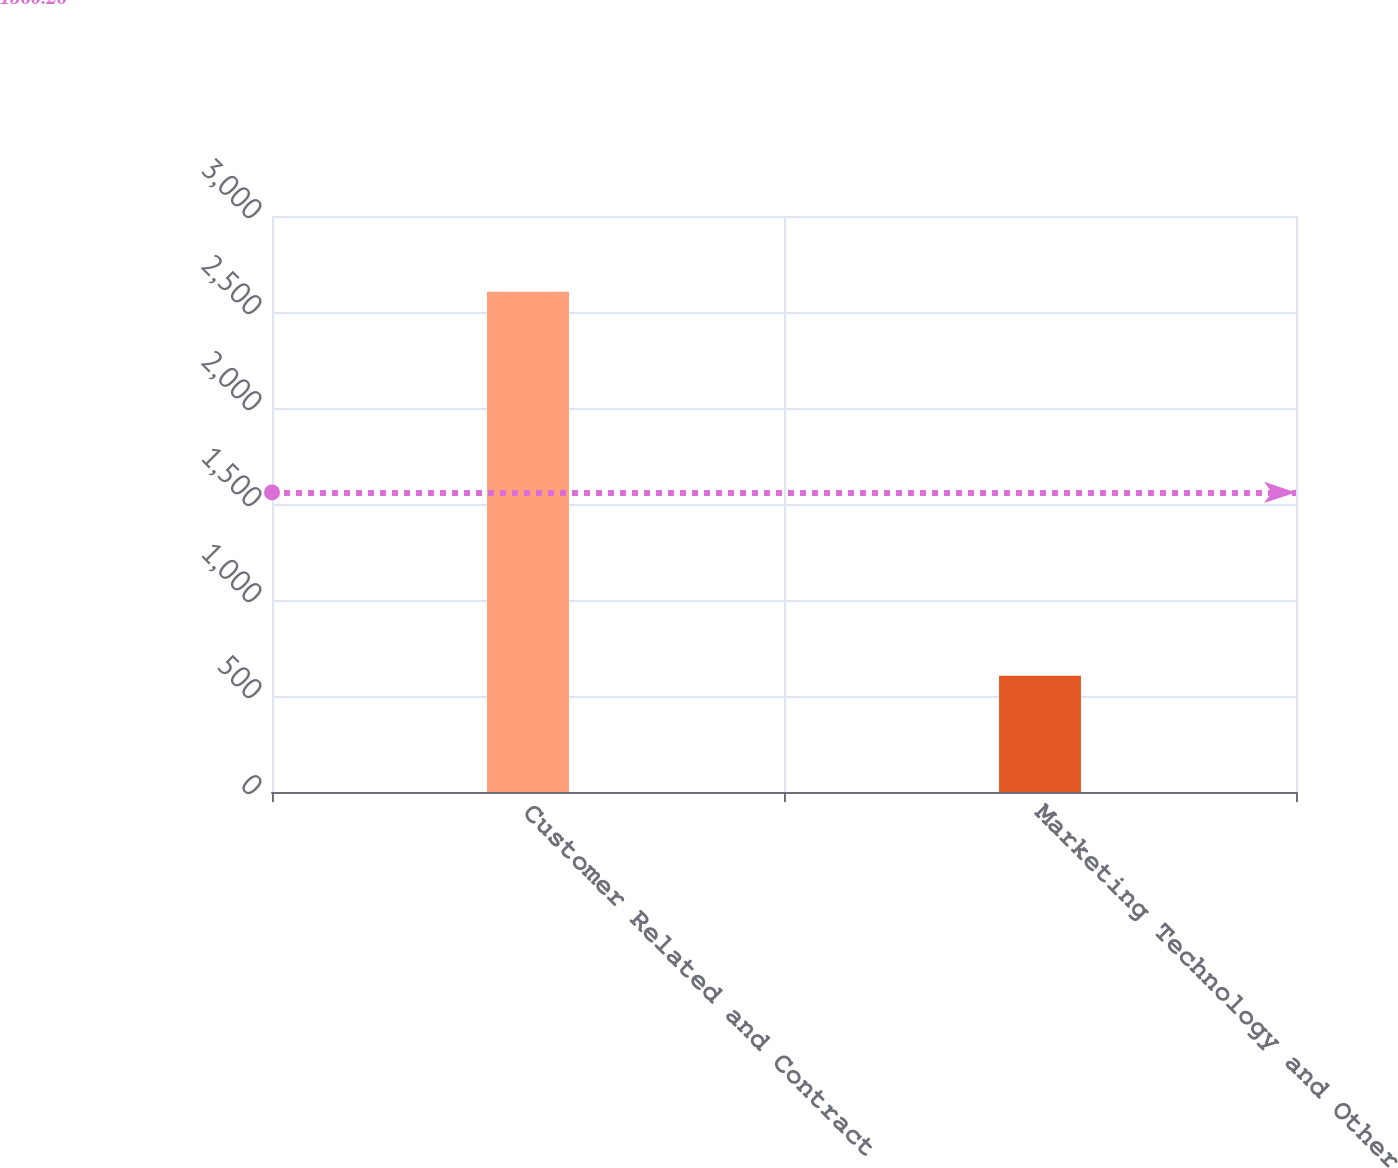<chart> <loc_0><loc_0><loc_500><loc_500><bar_chart><fcel>Customer Related and Contract<fcel>Marketing Technology and Other<nl><fcel>2605<fcel>606<nl></chart> 